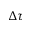<formula> <loc_0><loc_0><loc_500><loc_500>\Delta \tau</formula> 